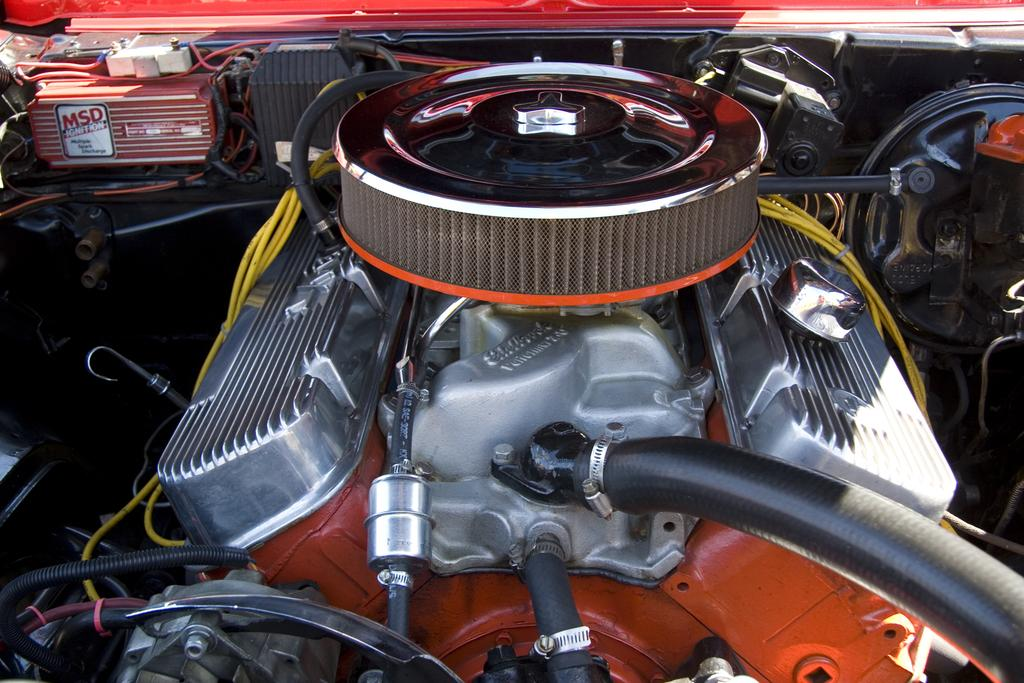What is the main subject of the image? The main subject of the image is an engine of a vehicle. What component is located at the front of the engine? There is a radiator in the front of the engine. What type of elements are present within the engine? Pipes and wires are visible in the engine. What color of paint is used on the stove in the image? There is no stove present in the image; it features an engine of a vehicle. How is the distribution of heat managed within the engine? The provided facts do not mention any specific heat distribution mechanisms within the engine. 